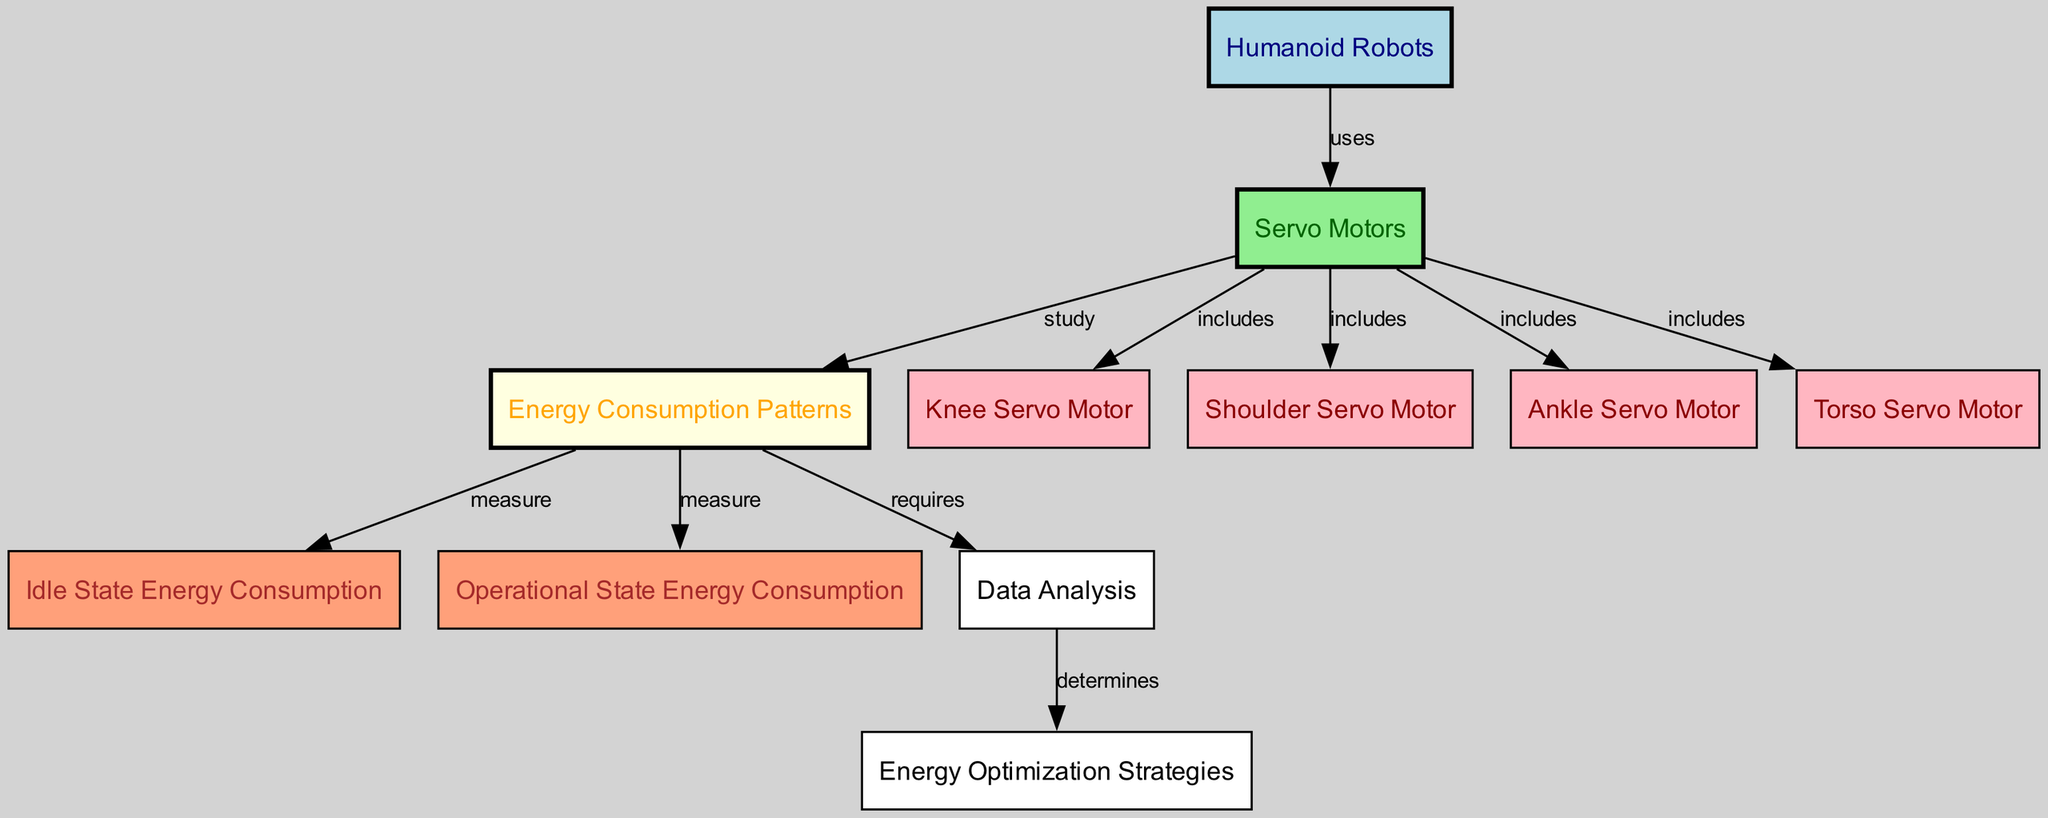What is the total number of nodes in the diagram? The nodes listed in the diagram include Humanoid Robots, Servo Motors, Energy Consumption Patterns, Knee Servo Motor, Shoulder Servo Motor, Ankle Servo Motor, Torso Servo Motor, Idle State Energy Consumption, Operational State Energy Consumption, Data Analysis, and Energy Optimization Strategies. Counting these, we find that there are 11 nodes in total.
Answer: 11 What do the Servo Motors measure? The edges from the Energy Consumption Patterns node indicate they measure Idle State Energy Consumption and Operational State Energy Consumption, showing the actions directly related to servo motors.
Answer: Idle State Energy Consumption and Operational State Energy Consumption Which node describes energy optimization? The edge from Data Analysis leads to the Energy Optimization Strategies node, indicating that energy optimization strategies are derived from the analysis conducted on energy consumption patterns of the servo motors.
Answer: Energy Optimization Strategies How are Servo Motors related to Humanoid Robots? The diagram shows a direct edge labeled "uses" from the Humanoid Robots node to the Servo Motors node, signifying that humanoid robots utilize servo motors in their design.
Answer: uses What types of energy consumption are measured in the diagram? The diagram specifies two distinct types of energy consumption being measured which are linked to the Energy Consumption Patterns node: Idle State Energy Consumption and Operational State Energy Consumption. These highlight the difference between the power drawn during non-motion and motion states of servo motors.
Answer: Idle State Energy Consumption and Operational State Energy Consumption Which part of the diagram indicates the relationship between data analysis and energy optimization? The diagram illustrates this relationship through the edge from the Data Analysis node directed to the Energy Optimization Strategies node, indicating that effective strategies for optimization are determined based on analyzed data.
Answer: determines How many edges link from the Servo Motors node, and what do they describe? From the Servo Motors node, there are four edges linking to the nodes representing each type of servo motor: Knee Servo Motor, Shoulder Servo Motor, Ankle Servo Motor, and Torso Servo Motor. This indicates that different servo motors are included and contribute to the energy consumption study. There are four edges in total.
Answer: 4 What is required for measuring energy consumption patterns? The diagram shows an edge from the Energy Consumption Patterns node to the Data Analysis node, indicating that the process of measuring energy consumption requires data analysis to interpret the findings effectively.
Answer: Data Analysis 